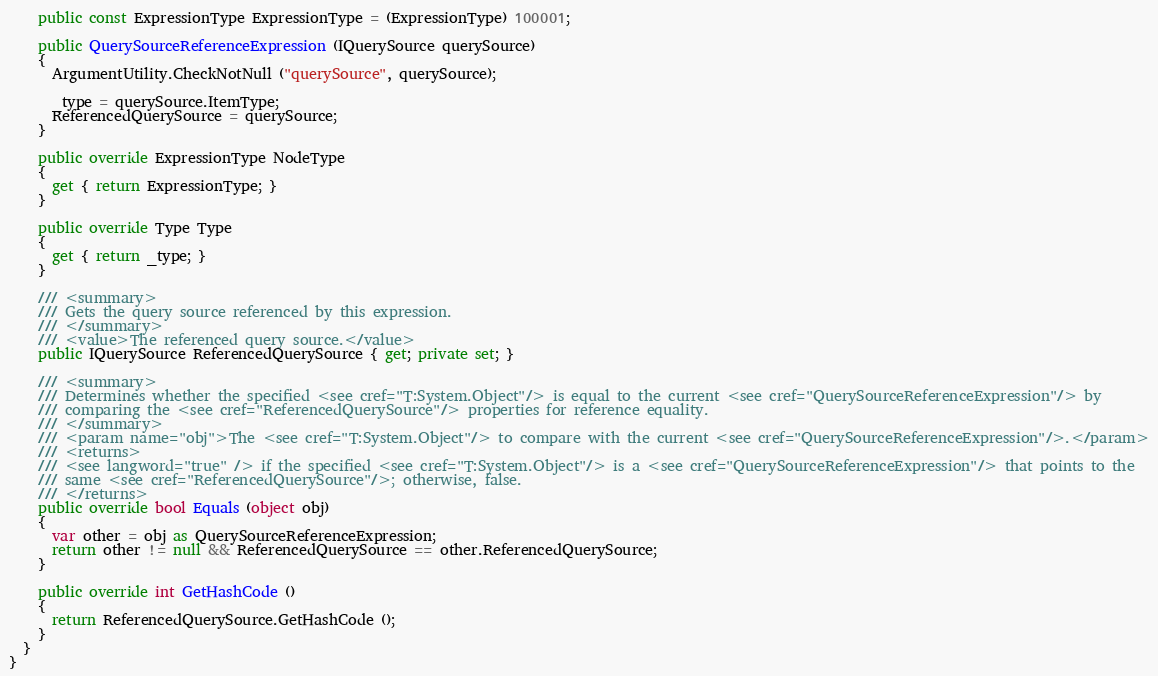<code> <loc_0><loc_0><loc_500><loc_500><_C#_>    public const ExpressionType ExpressionType = (ExpressionType) 100001;

    public QuerySourceReferenceExpression (IQuerySource querySource)
    {
      ArgumentUtility.CheckNotNull ("querySource", querySource);

      _type = querySource.ItemType;
      ReferencedQuerySource = querySource;
    }

    public override ExpressionType NodeType
    {
      get { return ExpressionType; }
    }

    public override Type Type
    {
      get { return _type; }
    }
    
    /// <summary>
    /// Gets the query source referenced by this expression.
    /// </summary>
    /// <value>The referenced query source.</value>
    public IQuerySource ReferencedQuerySource { get; private set; }

    /// <summary>
    /// Determines whether the specified <see cref="T:System.Object"/> is equal to the current <see cref="QuerySourceReferenceExpression"/> by 
    /// comparing the <see cref="ReferencedQuerySource"/> properties for reference equality.
    /// </summary>
    /// <param name="obj">The <see cref="T:System.Object"/> to compare with the current <see cref="QuerySourceReferenceExpression"/>.</param>
    /// <returns>
    /// <see langword="true" /> if the specified <see cref="T:System.Object"/> is a <see cref="QuerySourceReferenceExpression"/> that points to the 
    /// same <see cref="ReferencedQuerySource"/>; otherwise, false.
    /// </returns>
    public override bool Equals (object obj)
    {
      var other = obj as QuerySourceReferenceExpression;
      return other != null && ReferencedQuerySource == other.ReferencedQuerySource;
    }

    public override int GetHashCode ()
    {
      return ReferencedQuerySource.GetHashCode ();
    }
  }
}
</code> 